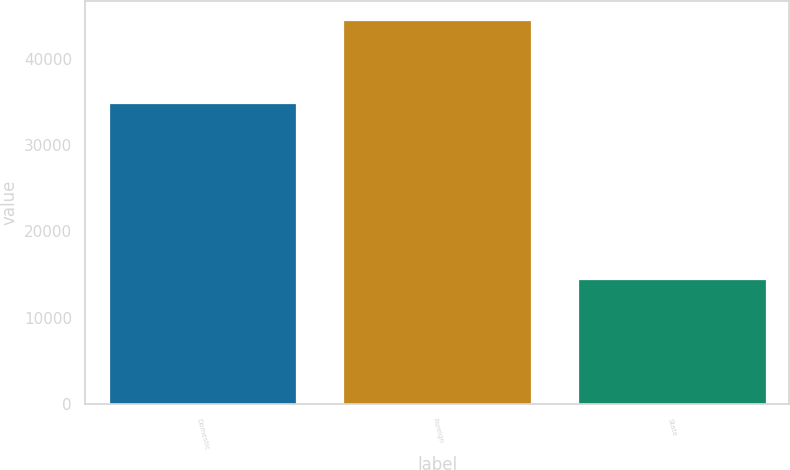<chart> <loc_0><loc_0><loc_500><loc_500><bar_chart><fcel>Domestic<fcel>Foreign<fcel>State<nl><fcel>34880<fcel>44434<fcel>14483<nl></chart> 